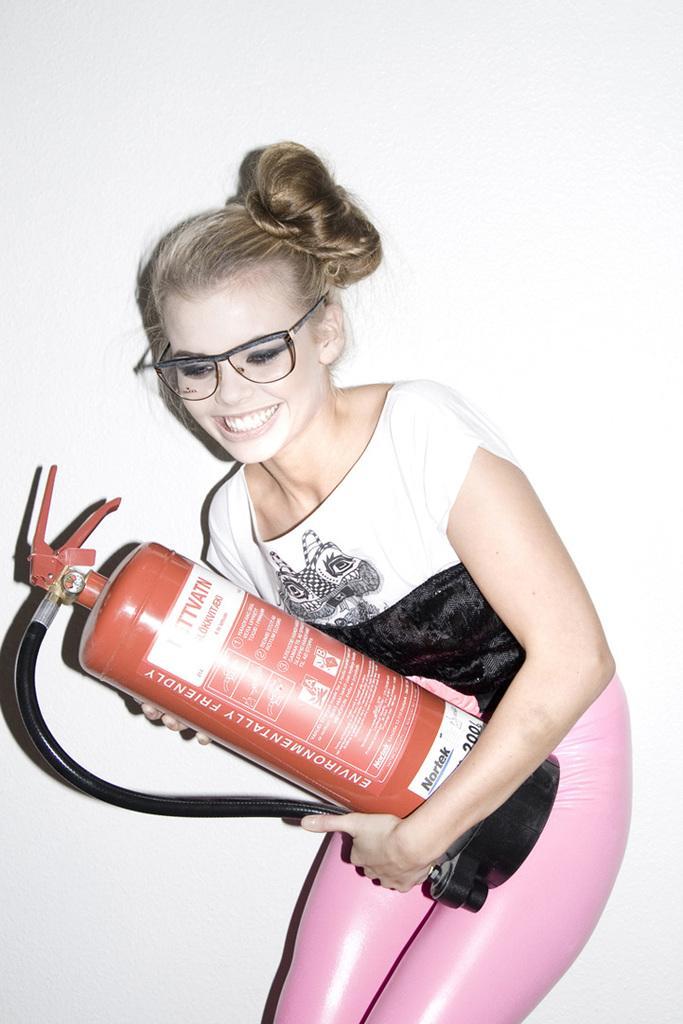In one or two sentences, can you explain what this image depicts? In this image there is one woman who is wearing spectacles and she is holding a cylinder, and in the background there is wall. 